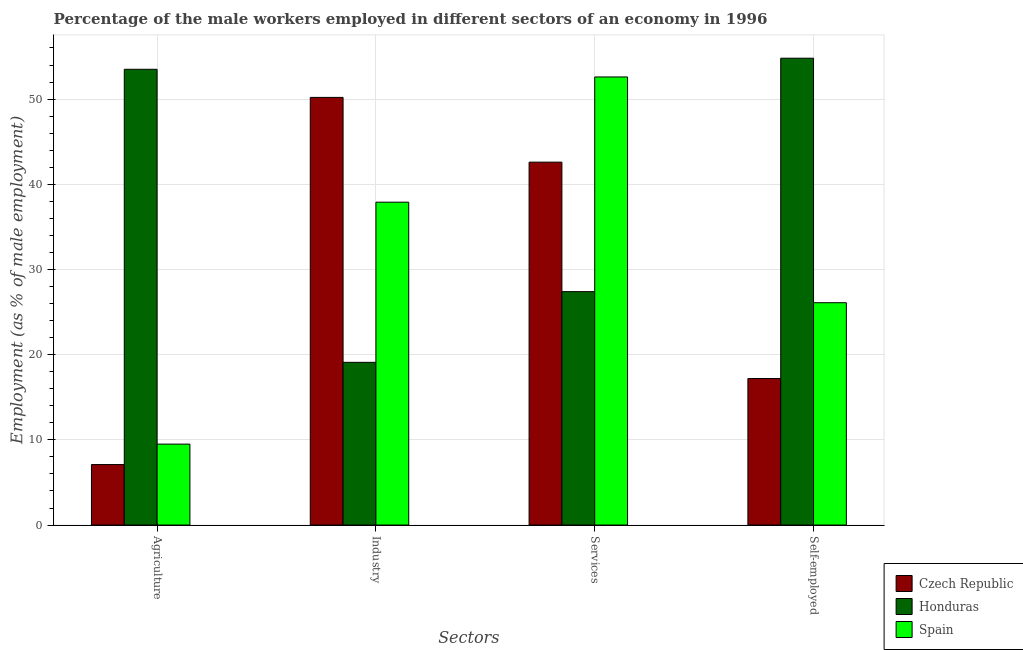How many different coloured bars are there?
Offer a very short reply. 3. Are the number of bars on each tick of the X-axis equal?
Make the answer very short. Yes. How many bars are there on the 2nd tick from the left?
Keep it short and to the point. 3. How many bars are there on the 4th tick from the right?
Your answer should be very brief. 3. What is the label of the 3rd group of bars from the left?
Provide a short and direct response. Services. What is the percentage of male workers in services in Honduras?
Give a very brief answer. 27.4. Across all countries, what is the maximum percentage of self employed male workers?
Offer a terse response. 54.8. Across all countries, what is the minimum percentage of self employed male workers?
Keep it short and to the point. 17.2. In which country was the percentage of male workers in agriculture maximum?
Offer a very short reply. Honduras. In which country was the percentage of male workers in industry minimum?
Offer a very short reply. Honduras. What is the total percentage of male workers in agriculture in the graph?
Your response must be concise. 70.1. What is the difference between the percentage of self employed male workers in Spain and that in Honduras?
Provide a short and direct response. -28.7. What is the difference between the percentage of male workers in services in Honduras and the percentage of male workers in industry in Spain?
Make the answer very short. -10.5. What is the average percentage of male workers in agriculture per country?
Your answer should be very brief. 23.37. What is the difference between the percentage of self employed male workers and percentage of male workers in services in Spain?
Your answer should be compact. -26.5. What is the ratio of the percentage of male workers in services in Honduras to that in Czech Republic?
Keep it short and to the point. 0.64. Is the percentage of male workers in services in Honduras less than that in Czech Republic?
Provide a short and direct response. Yes. What is the difference between the highest and the second highest percentage of self employed male workers?
Your response must be concise. 28.7. What is the difference between the highest and the lowest percentage of male workers in services?
Offer a very short reply. 25.2. Is the sum of the percentage of male workers in industry in Honduras and Czech Republic greater than the maximum percentage of self employed male workers across all countries?
Your answer should be compact. Yes. What does the 2nd bar from the left in Agriculture represents?
Keep it short and to the point. Honduras. What does the 3rd bar from the right in Agriculture represents?
Your answer should be very brief. Czech Republic. Is it the case that in every country, the sum of the percentage of male workers in agriculture and percentage of male workers in industry is greater than the percentage of male workers in services?
Give a very brief answer. No. How many bars are there?
Keep it short and to the point. 12. Are all the bars in the graph horizontal?
Keep it short and to the point. No. What is the difference between two consecutive major ticks on the Y-axis?
Make the answer very short. 10. Are the values on the major ticks of Y-axis written in scientific E-notation?
Keep it short and to the point. No. Does the graph contain any zero values?
Make the answer very short. No. Does the graph contain grids?
Make the answer very short. Yes. How many legend labels are there?
Your response must be concise. 3. How are the legend labels stacked?
Offer a very short reply. Vertical. What is the title of the graph?
Offer a terse response. Percentage of the male workers employed in different sectors of an economy in 1996. What is the label or title of the X-axis?
Your answer should be very brief. Sectors. What is the label or title of the Y-axis?
Make the answer very short. Employment (as % of male employment). What is the Employment (as % of male employment) in Czech Republic in Agriculture?
Provide a short and direct response. 7.1. What is the Employment (as % of male employment) in Honduras in Agriculture?
Keep it short and to the point. 53.5. What is the Employment (as % of male employment) of Czech Republic in Industry?
Your answer should be compact. 50.2. What is the Employment (as % of male employment) of Honduras in Industry?
Offer a very short reply. 19.1. What is the Employment (as % of male employment) of Spain in Industry?
Your answer should be compact. 37.9. What is the Employment (as % of male employment) in Czech Republic in Services?
Your response must be concise. 42.6. What is the Employment (as % of male employment) of Honduras in Services?
Your answer should be very brief. 27.4. What is the Employment (as % of male employment) in Spain in Services?
Your response must be concise. 52.6. What is the Employment (as % of male employment) of Czech Republic in Self-employed?
Offer a terse response. 17.2. What is the Employment (as % of male employment) in Honduras in Self-employed?
Make the answer very short. 54.8. What is the Employment (as % of male employment) in Spain in Self-employed?
Give a very brief answer. 26.1. Across all Sectors, what is the maximum Employment (as % of male employment) of Czech Republic?
Your response must be concise. 50.2. Across all Sectors, what is the maximum Employment (as % of male employment) of Honduras?
Your response must be concise. 54.8. Across all Sectors, what is the maximum Employment (as % of male employment) in Spain?
Provide a short and direct response. 52.6. Across all Sectors, what is the minimum Employment (as % of male employment) in Czech Republic?
Offer a terse response. 7.1. Across all Sectors, what is the minimum Employment (as % of male employment) of Honduras?
Your answer should be compact. 19.1. What is the total Employment (as % of male employment) in Czech Republic in the graph?
Give a very brief answer. 117.1. What is the total Employment (as % of male employment) in Honduras in the graph?
Your answer should be very brief. 154.8. What is the total Employment (as % of male employment) in Spain in the graph?
Your answer should be compact. 126.1. What is the difference between the Employment (as % of male employment) of Czech Republic in Agriculture and that in Industry?
Ensure brevity in your answer.  -43.1. What is the difference between the Employment (as % of male employment) of Honduras in Agriculture and that in Industry?
Provide a succinct answer. 34.4. What is the difference between the Employment (as % of male employment) in Spain in Agriculture and that in Industry?
Your answer should be compact. -28.4. What is the difference between the Employment (as % of male employment) of Czech Republic in Agriculture and that in Services?
Ensure brevity in your answer.  -35.5. What is the difference between the Employment (as % of male employment) of Honduras in Agriculture and that in Services?
Your answer should be very brief. 26.1. What is the difference between the Employment (as % of male employment) in Spain in Agriculture and that in Services?
Your response must be concise. -43.1. What is the difference between the Employment (as % of male employment) of Czech Republic in Agriculture and that in Self-employed?
Keep it short and to the point. -10.1. What is the difference between the Employment (as % of male employment) in Spain in Agriculture and that in Self-employed?
Make the answer very short. -16.6. What is the difference between the Employment (as % of male employment) in Spain in Industry and that in Services?
Your answer should be very brief. -14.7. What is the difference between the Employment (as % of male employment) of Czech Republic in Industry and that in Self-employed?
Your answer should be compact. 33. What is the difference between the Employment (as % of male employment) in Honduras in Industry and that in Self-employed?
Offer a very short reply. -35.7. What is the difference between the Employment (as % of male employment) of Spain in Industry and that in Self-employed?
Give a very brief answer. 11.8. What is the difference between the Employment (as % of male employment) of Czech Republic in Services and that in Self-employed?
Ensure brevity in your answer.  25.4. What is the difference between the Employment (as % of male employment) in Honduras in Services and that in Self-employed?
Your answer should be compact. -27.4. What is the difference between the Employment (as % of male employment) of Spain in Services and that in Self-employed?
Make the answer very short. 26.5. What is the difference between the Employment (as % of male employment) in Czech Republic in Agriculture and the Employment (as % of male employment) in Spain in Industry?
Make the answer very short. -30.8. What is the difference between the Employment (as % of male employment) of Honduras in Agriculture and the Employment (as % of male employment) of Spain in Industry?
Provide a succinct answer. 15.6. What is the difference between the Employment (as % of male employment) in Czech Republic in Agriculture and the Employment (as % of male employment) in Honduras in Services?
Provide a succinct answer. -20.3. What is the difference between the Employment (as % of male employment) of Czech Republic in Agriculture and the Employment (as % of male employment) of Spain in Services?
Provide a short and direct response. -45.5. What is the difference between the Employment (as % of male employment) in Honduras in Agriculture and the Employment (as % of male employment) in Spain in Services?
Offer a very short reply. 0.9. What is the difference between the Employment (as % of male employment) of Czech Republic in Agriculture and the Employment (as % of male employment) of Honduras in Self-employed?
Keep it short and to the point. -47.7. What is the difference between the Employment (as % of male employment) of Czech Republic in Agriculture and the Employment (as % of male employment) of Spain in Self-employed?
Give a very brief answer. -19. What is the difference between the Employment (as % of male employment) in Honduras in Agriculture and the Employment (as % of male employment) in Spain in Self-employed?
Make the answer very short. 27.4. What is the difference between the Employment (as % of male employment) in Czech Republic in Industry and the Employment (as % of male employment) in Honduras in Services?
Provide a short and direct response. 22.8. What is the difference between the Employment (as % of male employment) in Czech Republic in Industry and the Employment (as % of male employment) in Spain in Services?
Ensure brevity in your answer.  -2.4. What is the difference between the Employment (as % of male employment) of Honduras in Industry and the Employment (as % of male employment) of Spain in Services?
Your response must be concise. -33.5. What is the difference between the Employment (as % of male employment) in Czech Republic in Industry and the Employment (as % of male employment) in Spain in Self-employed?
Your response must be concise. 24.1. What is the difference between the Employment (as % of male employment) in Czech Republic in Services and the Employment (as % of male employment) in Honduras in Self-employed?
Provide a short and direct response. -12.2. What is the average Employment (as % of male employment) in Czech Republic per Sectors?
Give a very brief answer. 29.27. What is the average Employment (as % of male employment) in Honduras per Sectors?
Offer a terse response. 38.7. What is the average Employment (as % of male employment) of Spain per Sectors?
Ensure brevity in your answer.  31.52. What is the difference between the Employment (as % of male employment) of Czech Republic and Employment (as % of male employment) of Honduras in Agriculture?
Make the answer very short. -46.4. What is the difference between the Employment (as % of male employment) in Czech Republic and Employment (as % of male employment) in Spain in Agriculture?
Your response must be concise. -2.4. What is the difference between the Employment (as % of male employment) of Czech Republic and Employment (as % of male employment) of Honduras in Industry?
Your answer should be compact. 31.1. What is the difference between the Employment (as % of male employment) of Honduras and Employment (as % of male employment) of Spain in Industry?
Provide a short and direct response. -18.8. What is the difference between the Employment (as % of male employment) of Czech Republic and Employment (as % of male employment) of Honduras in Services?
Your response must be concise. 15.2. What is the difference between the Employment (as % of male employment) in Czech Republic and Employment (as % of male employment) in Spain in Services?
Your response must be concise. -10. What is the difference between the Employment (as % of male employment) of Honduras and Employment (as % of male employment) of Spain in Services?
Ensure brevity in your answer.  -25.2. What is the difference between the Employment (as % of male employment) of Czech Republic and Employment (as % of male employment) of Honduras in Self-employed?
Offer a very short reply. -37.6. What is the difference between the Employment (as % of male employment) of Czech Republic and Employment (as % of male employment) of Spain in Self-employed?
Your answer should be compact. -8.9. What is the difference between the Employment (as % of male employment) of Honduras and Employment (as % of male employment) of Spain in Self-employed?
Make the answer very short. 28.7. What is the ratio of the Employment (as % of male employment) in Czech Republic in Agriculture to that in Industry?
Offer a terse response. 0.14. What is the ratio of the Employment (as % of male employment) of Honduras in Agriculture to that in Industry?
Offer a terse response. 2.8. What is the ratio of the Employment (as % of male employment) in Spain in Agriculture to that in Industry?
Make the answer very short. 0.25. What is the ratio of the Employment (as % of male employment) in Czech Republic in Agriculture to that in Services?
Offer a terse response. 0.17. What is the ratio of the Employment (as % of male employment) of Honduras in Agriculture to that in Services?
Make the answer very short. 1.95. What is the ratio of the Employment (as % of male employment) in Spain in Agriculture to that in Services?
Give a very brief answer. 0.18. What is the ratio of the Employment (as % of male employment) in Czech Republic in Agriculture to that in Self-employed?
Keep it short and to the point. 0.41. What is the ratio of the Employment (as % of male employment) of Honduras in Agriculture to that in Self-employed?
Provide a short and direct response. 0.98. What is the ratio of the Employment (as % of male employment) of Spain in Agriculture to that in Self-employed?
Give a very brief answer. 0.36. What is the ratio of the Employment (as % of male employment) of Czech Republic in Industry to that in Services?
Your answer should be compact. 1.18. What is the ratio of the Employment (as % of male employment) in Honduras in Industry to that in Services?
Make the answer very short. 0.7. What is the ratio of the Employment (as % of male employment) of Spain in Industry to that in Services?
Your answer should be very brief. 0.72. What is the ratio of the Employment (as % of male employment) in Czech Republic in Industry to that in Self-employed?
Give a very brief answer. 2.92. What is the ratio of the Employment (as % of male employment) in Honduras in Industry to that in Self-employed?
Offer a terse response. 0.35. What is the ratio of the Employment (as % of male employment) of Spain in Industry to that in Self-employed?
Offer a very short reply. 1.45. What is the ratio of the Employment (as % of male employment) of Czech Republic in Services to that in Self-employed?
Keep it short and to the point. 2.48. What is the ratio of the Employment (as % of male employment) in Honduras in Services to that in Self-employed?
Provide a succinct answer. 0.5. What is the ratio of the Employment (as % of male employment) of Spain in Services to that in Self-employed?
Your answer should be very brief. 2.02. What is the difference between the highest and the second highest Employment (as % of male employment) in Czech Republic?
Provide a short and direct response. 7.6. What is the difference between the highest and the second highest Employment (as % of male employment) of Spain?
Your response must be concise. 14.7. What is the difference between the highest and the lowest Employment (as % of male employment) in Czech Republic?
Make the answer very short. 43.1. What is the difference between the highest and the lowest Employment (as % of male employment) in Honduras?
Your answer should be compact. 35.7. What is the difference between the highest and the lowest Employment (as % of male employment) of Spain?
Give a very brief answer. 43.1. 